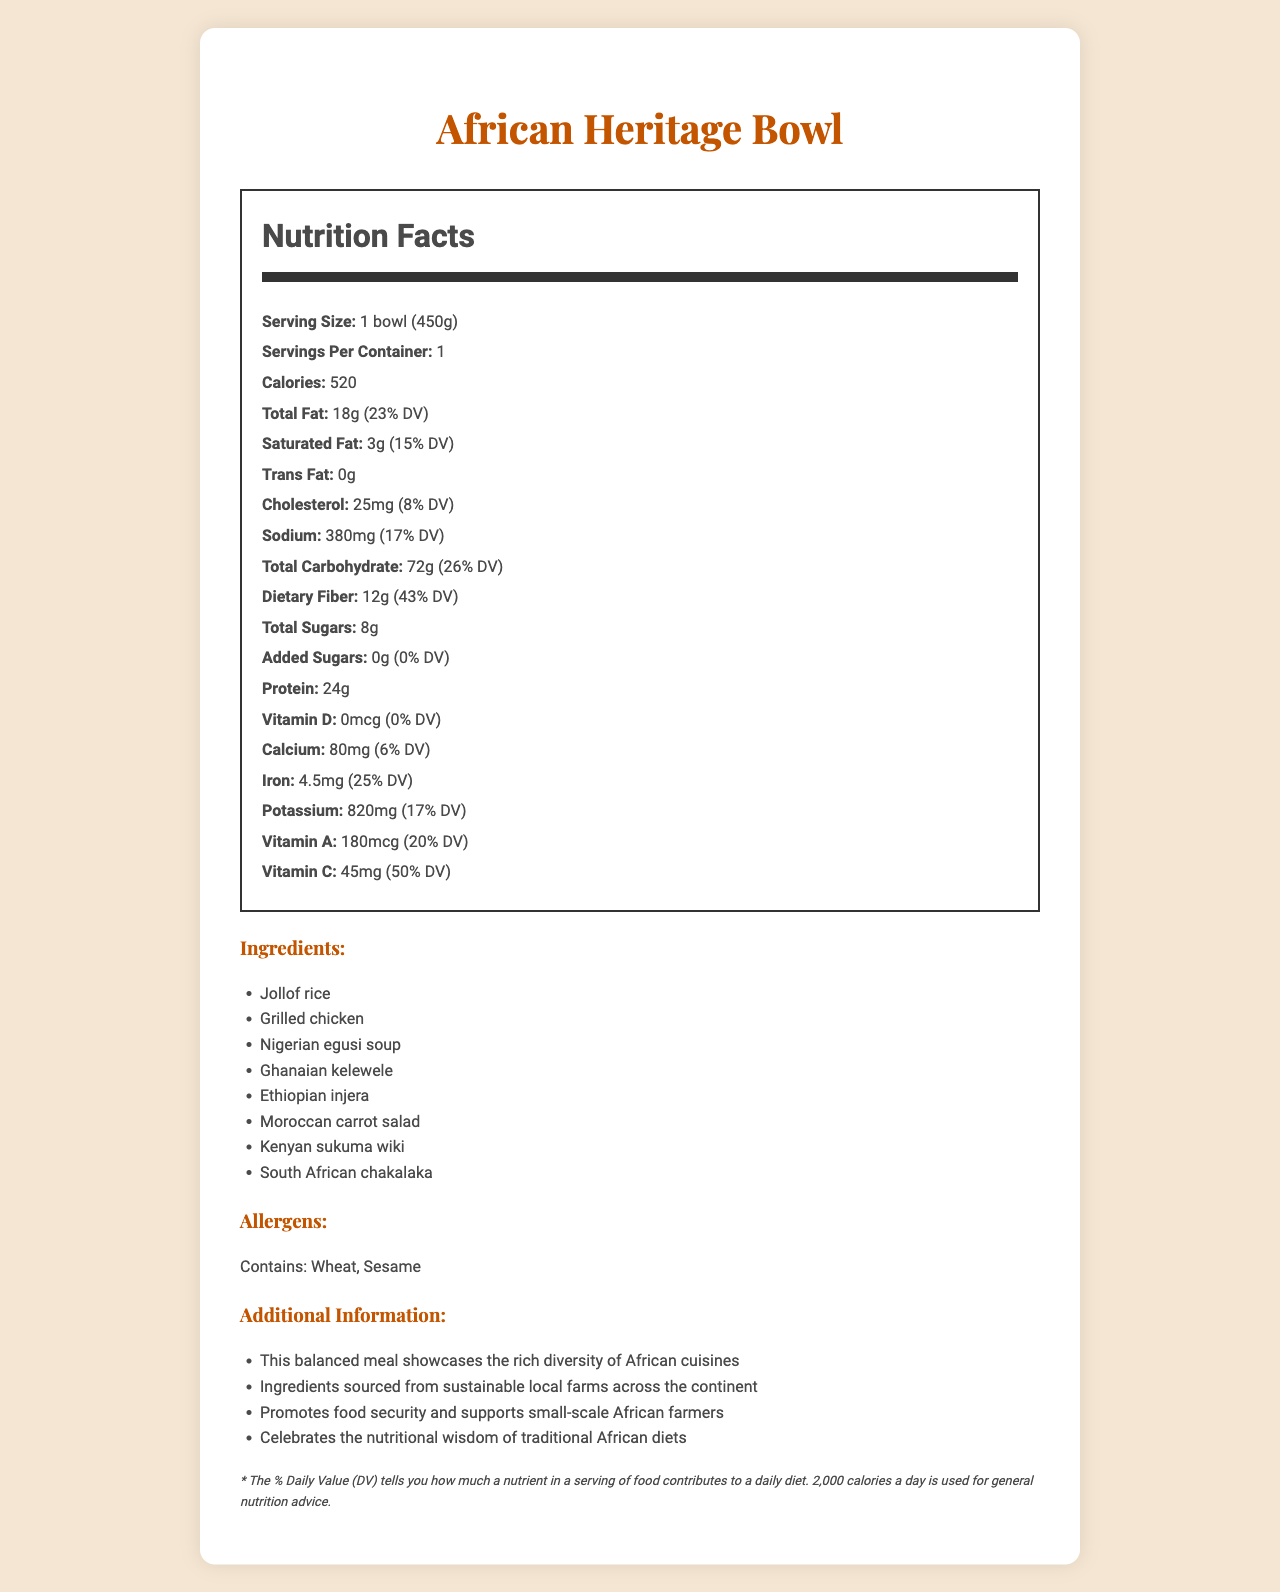what is the serving size of the African Heritage Bowl? The serving size is explicitly mentioned at the beginning of the nutrition facts label.
Answer: 1 bowl (450g) how many calories are in one serving of the African Heritage Bowl? The number of calories per serving is clearly listed on the nutrition facts label.
Answer: 520 what is the daily value percentage of protein in the African Heritage Bowl? The nutrition facts label states that the bowl contains 24g of protein, which represents 48% of the daily value.
Answer: 48% how much dietary fiber does the African Heritage Bowl contain? The amount of dietary fiber is listed as 12g on the nutrition facts label.
Answer: 12g what is the percentage of daily value for iron in the African Heritage Bowl? The nutrition facts label indicates that iron represents 25% of the daily value.
Answer: 25% which ingredient in the African Heritage Bowl might be a concern for people with sesame allergies? The allergens list mentions that the bowl contains sesame, and chakalaka is an African dish known to sometimes include sesame.
Answer: South African chakalaka what is the amount of sodium per serving in the African Heritage Bowl? The amount of sodium is listed as 380mg on the nutrition facts label.
Answer: 380mg how many grams of total fat are in the African Heritage Bowl? The nutrition facts label indicates that the total fat content is 18g.
Answer: 18g what is the main idea of the African Heritage Bowl's document? This document provides detailed nutritional information about the African Heritage Bowl, along with ingredients, allergens, and additional information emphasizing its cultural and sustainable aspects.
Answer: The African Heritage Bowl is a balanced meal inspired by diverse African cuisines, highlighting nutritional value and sustainability. how many servings are in one container of the African Heritage Bowl? The nutrition facts label clearly states that there are 1 serving per container.
Answer: 1 How much Vitamin C is present per serving? The amount of Vitamin C is listed as 45mg on the nutrition facts label.
Answer: 45mg what are some of the main ingredients in the African Heritage Bowl? A. Paneer B. Grilled Chicken C. Ethiopian injera D. Ghanaian kelewele Paneer is not listed among the ingredients, whereas grilled chicken, Ethiopian injera, and Ghanaian kelewele are.
Answer: B, C, D which of the following vitamins is not present in the African Heritage Bowl? I. Vitamin A II. Vitamin D III. Vitamin C IV. Vitamin E The nutrition facts label lists Vitamin A, Vitamin D, and Vitamin C but does not mention Vitamin E.
Answer: IV. Vitamin E Is there any trans fat in the African Heritage Bowl? The nutrition facts label lists the trans fat amount as 0g.
Answer: No can you tell how many grams of added sugars are in the African Heritage Bowl? The nutrition facts label indicates that the bowl contains 0g of added sugars.
Answer: 0g which statement is true about the African Heritage Bowl? A. It contains paneer. B. It has 15% daily value of saturated fat. C. It contains soy. The nutrition facts label shows that the bowl has 3g of saturated fat, representing 15% of the daily value. Paneer and soy are not listed among the ingredients.
Answer: B. It has 15% daily value of saturated fat. what is the calcium percentage of daily value? The nutrition facts label indicates that the calcium content represents 6% of the daily value.
Answer: 6% where are the ingredients sourced from for the African Heritage Bowl? The document mentions that the ingredients are sourced from sustainable local farms across the continent, but specific locations are not provided.
Answer: Not enough information 